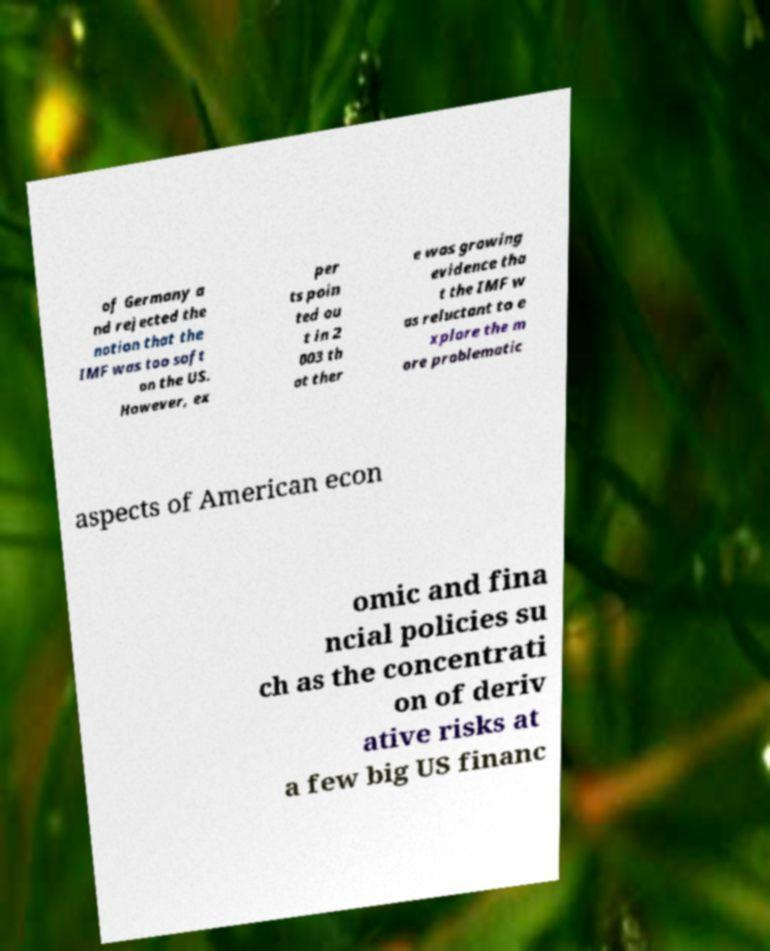Could you assist in decoding the text presented in this image and type it out clearly? of Germany a nd rejected the notion that the IMF was too soft on the US. However, ex per ts poin ted ou t in 2 003 th at ther e was growing evidence tha t the IMF w as reluctant to e xplore the m ore problematic aspects of American econ omic and fina ncial policies su ch as the concentrati on of deriv ative risks at a few big US financ 